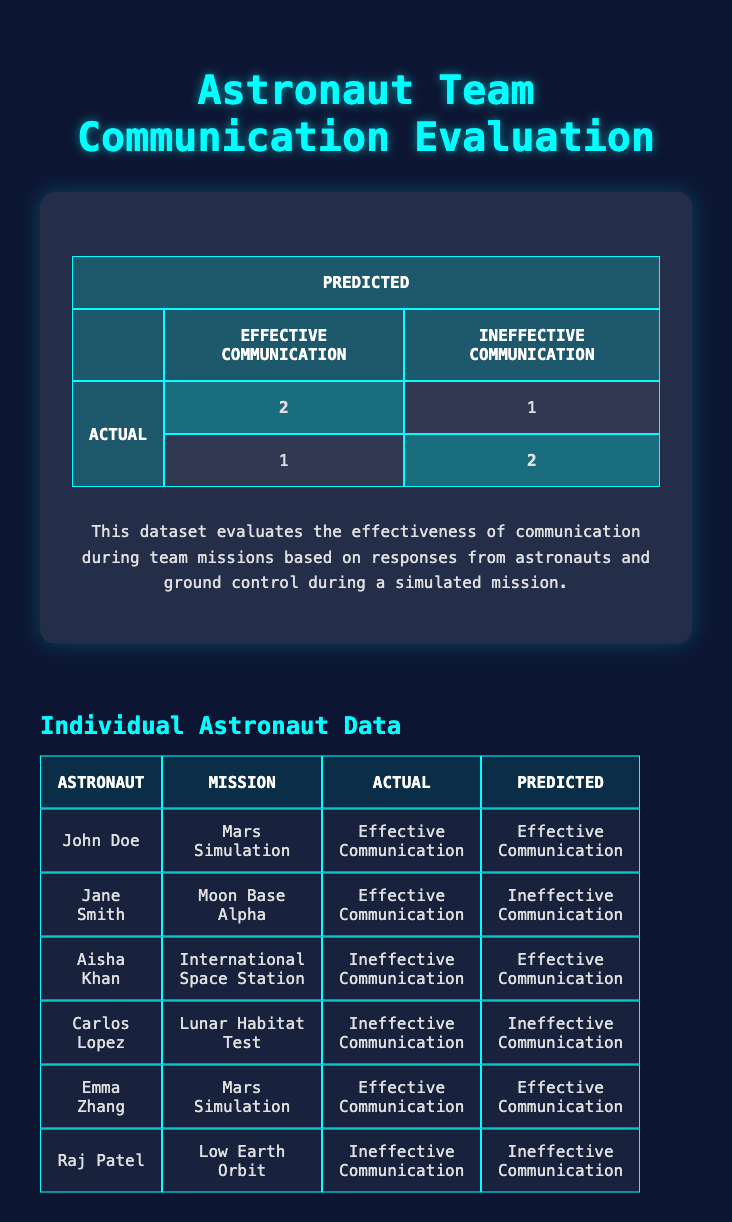What is the total number of instances of effective communication? In the table, there are 2 instances where the actual communication is labeled as "Effective Communication" (John Doe and Emma Zhang) and 2 instances predicted as "Effective Communication" in the model (John Doe and Emma Zhang). Therefore, the total count is 2.
Answer: 2 How many astronauts experienced ineffective communication? The table has 3 instances marked as "Ineffective Communication" under the "Actual" column (Aisha Khan, Carlos Lopez, Raj Patel). Thus, a total of 3 astronauts experienced ineffective communication.
Answer: 3 What percentage of the predictions were correct? There are a total of 6 predictions. To find the number of correct predictions, we identify 4 correct ones: John Doe, Carlos Lopez, Emma Zhang, and Raj Patel (2 effective + 2 ineffective). Therefore, the percentage of correct predictions is (4/6) * 100 = 66.67%.
Answer: 66.67% Did any astronauts experience a mismatch between their actual and predicted communication effectiveness? Yes, there are mismatches where the actual communication differed from the predicted. Jane Smith (effective actual, ineffective predicted) and Aisha Khan (ineffective actual, effective predicted) both experienced a mismatch.
Answer: Yes Which astronaut had the most effective communication according to the predictions? According to the predictions, both John Doe and Emma Zhang had effective communication predicted. However, in terms of actual communication, both were effective as well. Thus, both can be considered as having the most effective communication.
Answer: John Doe and Emma Zhang What is the difference in the number of effective communication cases between actual and predicted? The actual cases of effective communication are 4 (John Doe, Jane Smith, Emma Zhang), while the predicted cases are 3 (John Doe, Emma Zhang). Thus, the difference is 4 - 3 = 1.
Answer: 1 Which mission had an astronaut who predicted ineffective communication but had effective communication? The astronaut Aisha Khan on the mission to the International Space Station is the only one with a prediction of ineffective communication, while her actual communication was effective.
Answer: International Space Station How many astronauts successfully communicated effectively as predicted? Both John Doe and Emma Zhang had their actual communication and predictions aligned as effective. Thus, the number of astronauts who successfully communicated effectively according to the predictions is 2.
Answer: 2 Is there a case of a positive prediction where the actual result was ineffective communication? Yes, Aisha Khan is the astronaut who was predicted to have effective communication, but the actual outcome was ineffective communication.
Answer: Yes 